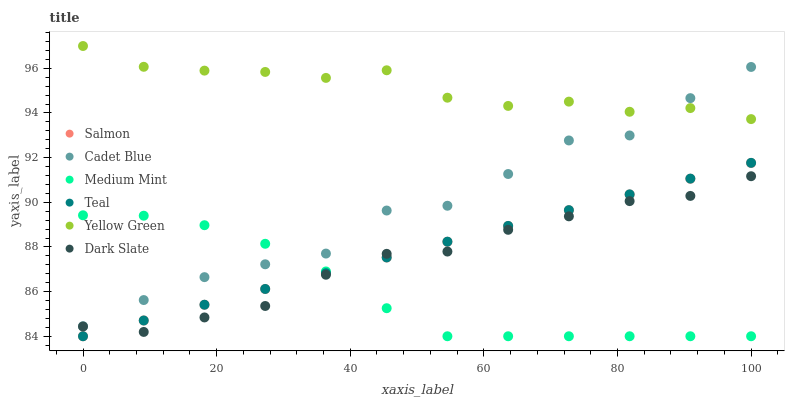Does Medium Mint have the minimum area under the curve?
Answer yes or no. Yes. Does Yellow Green have the maximum area under the curve?
Answer yes or no. Yes. Does Cadet Blue have the minimum area under the curve?
Answer yes or no. No. Does Cadet Blue have the maximum area under the curve?
Answer yes or no. No. Is Salmon the smoothest?
Answer yes or no. Yes. Is Cadet Blue the roughest?
Answer yes or no. Yes. Is Yellow Green the smoothest?
Answer yes or no. No. Is Yellow Green the roughest?
Answer yes or no. No. Does Medium Mint have the lowest value?
Answer yes or no. Yes. Does Cadet Blue have the lowest value?
Answer yes or no. No. Does Yellow Green have the highest value?
Answer yes or no. Yes. Does Cadet Blue have the highest value?
Answer yes or no. No. Is Salmon less than Yellow Green?
Answer yes or no. Yes. Is Cadet Blue greater than Salmon?
Answer yes or no. Yes. Does Cadet Blue intersect Medium Mint?
Answer yes or no. Yes. Is Cadet Blue less than Medium Mint?
Answer yes or no. No. Is Cadet Blue greater than Medium Mint?
Answer yes or no. No. Does Salmon intersect Yellow Green?
Answer yes or no. No. 